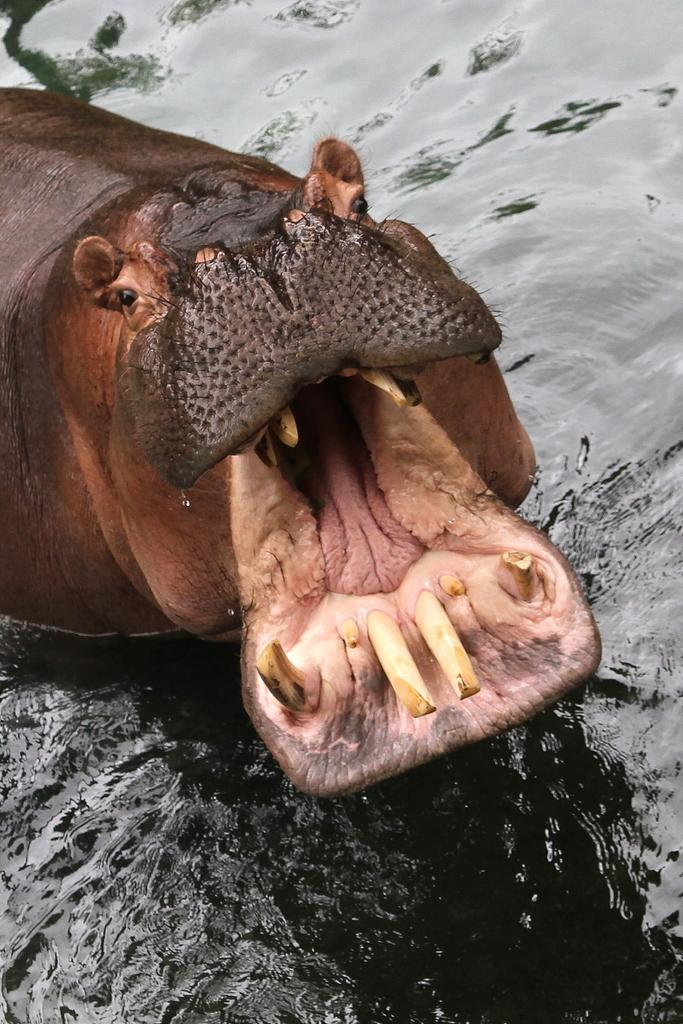What animal is in the image? There is a hippopotamus in the image. Where is the hippopotamus located? The hippopotamus is in water. What is the opinion of the sand in the image? There is no sand present in the image, so it is not possible to determine its opinion. 